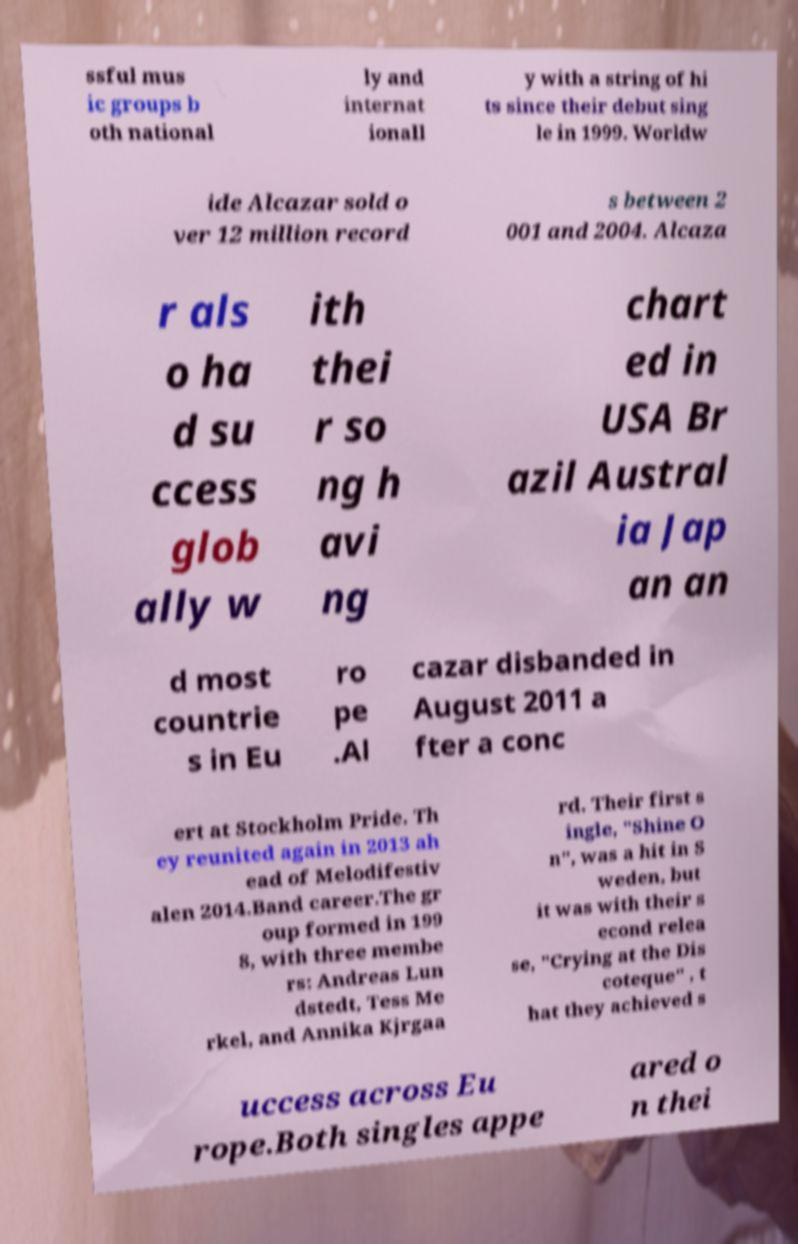There's text embedded in this image that I need extracted. Can you transcribe it verbatim? ssful mus ic groups b oth national ly and internat ionall y with a string of hi ts since their debut sing le in 1999. Worldw ide Alcazar sold o ver 12 million record s between 2 001 and 2004. Alcaza r als o ha d su ccess glob ally w ith thei r so ng h avi ng chart ed in USA Br azil Austral ia Jap an an d most countrie s in Eu ro pe .Al cazar disbanded in August 2011 a fter a conc ert at Stockholm Pride. Th ey reunited again in 2013 ah ead of Melodifestiv alen 2014.Band career.The gr oup formed in 199 8, with three membe rs: Andreas Lun dstedt, Tess Me rkel, and Annika Kjrgaa rd. Their first s ingle, "Shine O n", was a hit in S weden, but it was with their s econd relea se, "Crying at the Dis coteque" , t hat they achieved s uccess across Eu rope.Both singles appe ared o n thei 